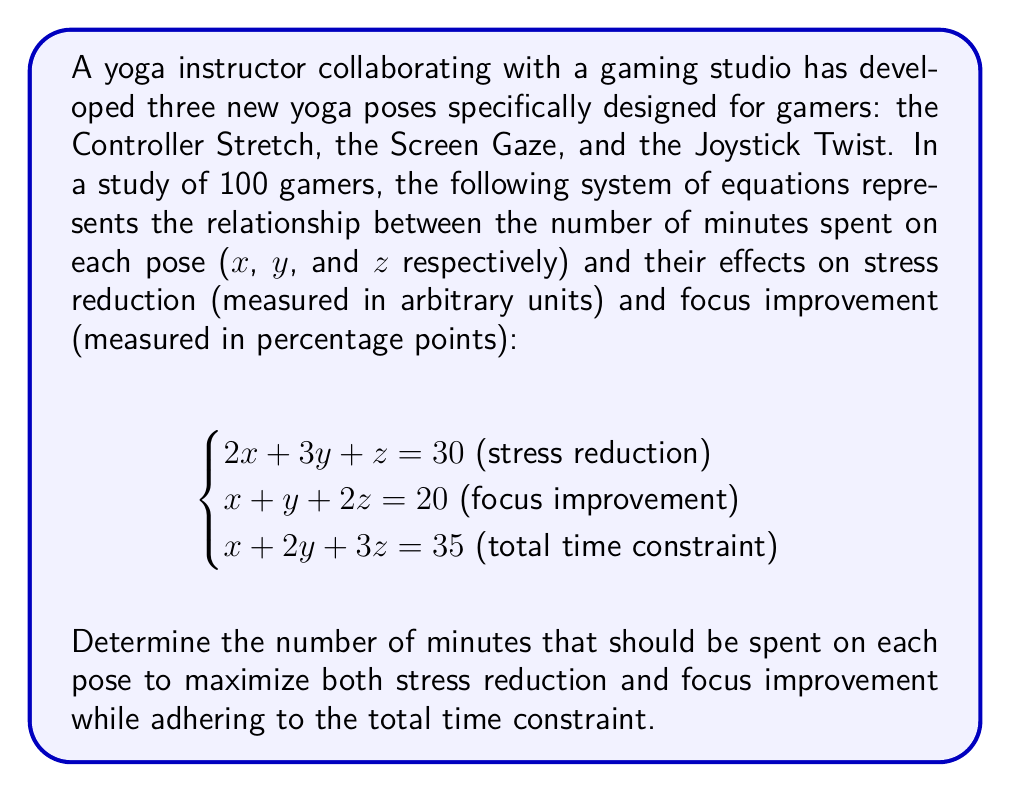What is the answer to this math problem? To solve this system of equations, we'll use the elimination method:

1) First, let's eliminate x by subtracting equation 1 from 2 times equation 2:

   $$2(x + y + 2z = 20)$$
   $$2x + 2y + 4z = 40$$
   $$-(2x + 3y + z = 30)$$
   $$-y + 3z = 10 \text{ (equation 4)}$$

2) Now, let's eliminate x by subtracting equation 1 from equation 3:

   $$x + 2y + 3z = 35$$
   $$-(2x + 3y + z = 30)$$
   $$-x - y + 2z = 5 \text{ (equation 5)}$$

3) We now have two equations with y and z:

   $$-y + 3z = 10 \text{ (equation 4)}$$
   $$-y + 2z = 5 \text{ (equation 5)}$$

4) Subtracting equation 5 from equation 4:

   $$z = 5$$

5) Substituting this back into equation 5:

   $$-y + 2(5) = 5$$
   $$-y + 10 = 5$$
   $$-y = -5$$
   $$y = 5$$

6) Now we can substitute y and z into equation 3 to find x:

   $$x + 2(5) + 3(5) = 35$$
   $$x + 10 + 15 = 35$$
   $$x = 10$$

Therefore, the optimal time spent on each pose is:
x (Controller Stretch) = 10 minutes
y (Screen Gaze) = 5 minutes
z (Joystick Twist) = 5 minutes

We can verify this solution satisfies all three equations:

Stress reduction: $2(10) + 3(5) + 5 = 20 + 15 + 5 = 40$
Focus improvement: $10 + 5 + 2(5) = 10 + 5 + 10 = 25$
Total time: $10 + 5 + 5 = 20$

These values maximize both stress reduction and focus improvement while adhering to the total time constraint.
Answer: Controller Stretch: 10 minutes
Screen Gaze: 5 minutes
Joystick Twist: 5 minutes 